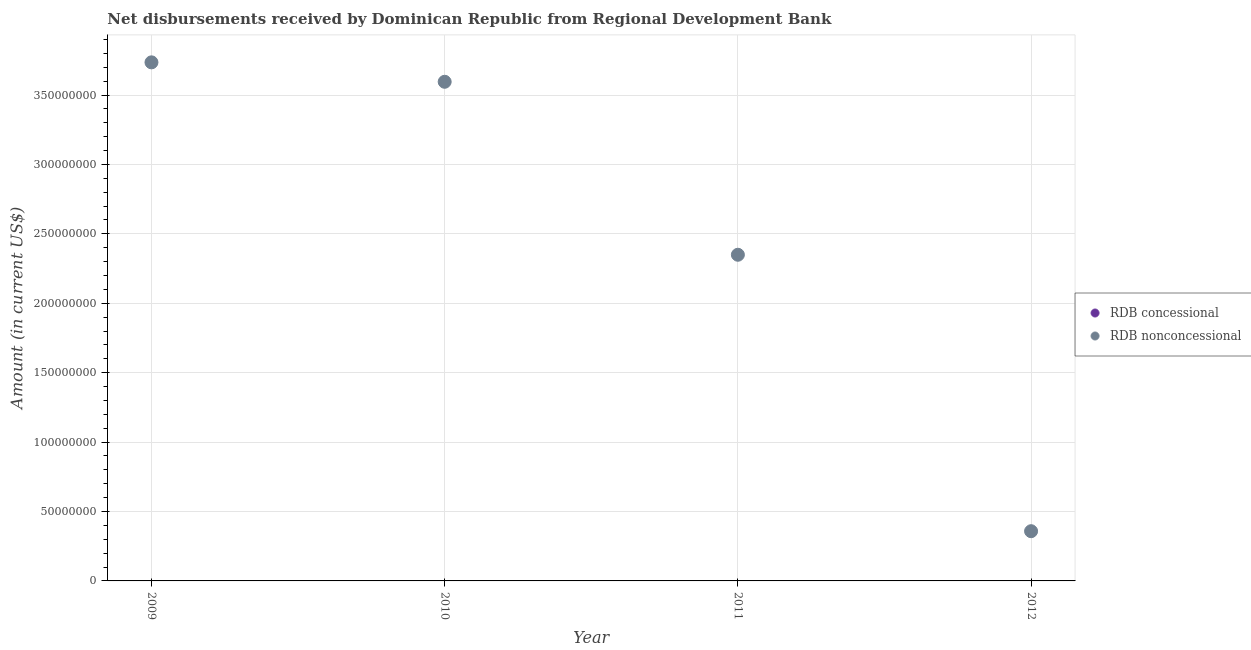Is the number of dotlines equal to the number of legend labels?
Keep it short and to the point. No. What is the net non concessional disbursements from rdb in 2009?
Your response must be concise. 3.74e+08. Across all years, what is the maximum net non concessional disbursements from rdb?
Your answer should be compact. 3.74e+08. Across all years, what is the minimum net non concessional disbursements from rdb?
Offer a terse response. 3.58e+07. In which year was the net non concessional disbursements from rdb maximum?
Make the answer very short. 2009. What is the total net non concessional disbursements from rdb in the graph?
Provide a succinct answer. 1.00e+09. What is the difference between the net non concessional disbursements from rdb in 2009 and that in 2010?
Your answer should be compact. 1.40e+07. What is the difference between the net concessional disbursements from rdb in 2011 and the net non concessional disbursements from rdb in 2012?
Your answer should be compact. -3.58e+07. In how many years, is the net non concessional disbursements from rdb greater than 320000000 US$?
Your answer should be very brief. 2. What is the ratio of the net non concessional disbursements from rdb in 2009 to that in 2010?
Your answer should be compact. 1.04. Is the net non concessional disbursements from rdb in 2009 less than that in 2010?
Your answer should be very brief. No. What is the difference between the highest and the second highest net non concessional disbursements from rdb?
Your answer should be compact. 1.40e+07. What is the difference between the highest and the lowest net non concessional disbursements from rdb?
Your answer should be very brief. 3.38e+08. In how many years, is the net concessional disbursements from rdb greater than the average net concessional disbursements from rdb taken over all years?
Give a very brief answer. 0. Does the net non concessional disbursements from rdb monotonically increase over the years?
Your answer should be compact. No. How many dotlines are there?
Give a very brief answer. 1. Does the graph contain any zero values?
Your answer should be compact. Yes. Where does the legend appear in the graph?
Your response must be concise. Center right. How many legend labels are there?
Offer a terse response. 2. How are the legend labels stacked?
Provide a succinct answer. Vertical. What is the title of the graph?
Provide a short and direct response. Net disbursements received by Dominican Republic from Regional Development Bank. What is the Amount (in current US$) in RDB concessional in 2009?
Provide a succinct answer. 0. What is the Amount (in current US$) of RDB nonconcessional in 2009?
Give a very brief answer. 3.74e+08. What is the Amount (in current US$) of RDB concessional in 2010?
Provide a short and direct response. 0. What is the Amount (in current US$) in RDB nonconcessional in 2010?
Your answer should be compact. 3.60e+08. What is the Amount (in current US$) in RDB nonconcessional in 2011?
Ensure brevity in your answer.  2.35e+08. What is the Amount (in current US$) of RDB concessional in 2012?
Provide a succinct answer. 0. What is the Amount (in current US$) in RDB nonconcessional in 2012?
Make the answer very short. 3.58e+07. Across all years, what is the maximum Amount (in current US$) in RDB nonconcessional?
Keep it short and to the point. 3.74e+08. Across all years, what is the minimum Amount (in current US$) in RDB nonconcessional?
Ensure brevity in your answer.  3.58e+07. What is the total Amount (in current US$) in RDB concessional in the graph?
Ensure brevity in your answer.  0. What is the total Amount (in current US$) of RDB nonconcessional in the graph?
Give a very brief answer. 1.00e+09. What is the difference between the Amount (in current US$) of RDB nonconcessional in 2009 and that in 2010?
Provide a short and direct response. 1.40e+07. What is the difference between the Amount (in current US$) of RDB nonconcessional in 2009 and that in 2011?
Offer a terse response. 1.39e+08. What is the difference between the Amount (in current US$) of RDB nonconcessional in 2009 and that in 2012?
Your answer should be very brief. 3.38e+08. What is the difference between the Amount (in current US$) in RDB nonconcessional in 2010 and that in 2011?
Offer a very short reply. 1.25e+08. What is the difference between the Amount (in current US$) in RDB nonconcessional in 2010 and that in 2012?
Give a very brief answer. 3.24e+08. What is the difference between the Amount (in current US$) of RDB nonconcessional in 2011 and that in 2012?
Your answer should be very brief. 1.99e+08. What is the average Amount (in current US$) in RDB nonconcessional per year?
Provide a short and direct response. 2.51e+08. What is the ratio of the Amount (in current US$) in RDB nonconcessional in 2009 to that in 2010?
Your answer should be very brief. 1.04. What is the ratio of the Amount (in current US$) in RDB nonconcessional in 2009 to that in 2011?
Your answer should be very brief. 1.59. What is the ratio of the Amount (in current US$) in RDB nonconcessional in 2009 to that in 2012?
Your answer should be compact. 10.43. What is the ratio of the Amount (in current US$) of RDB nonconcessional in 2010 to that in 2011?
Offer a terse response. 1.53. What is the ratio of the Amount (in current US$) in RDB nonconcessional in 2010 to that in 2012?
Provide a succinct answer. 10.04. What is the ratio of the Amount (in current US$) in RDB nonconcessional in 2011 to that in 2012?
Ensure brevity in your answer.  6.56. What is the difference between the highest and the second highest Amount (in current US$) of RDB nonconcessional?
Your answer should be compact. 1.40e+07. What is the difference between the highest and the lowest Amount (in current US$) in RDB nonconcessional?
Your answer should be compact. 3.38e+08. 